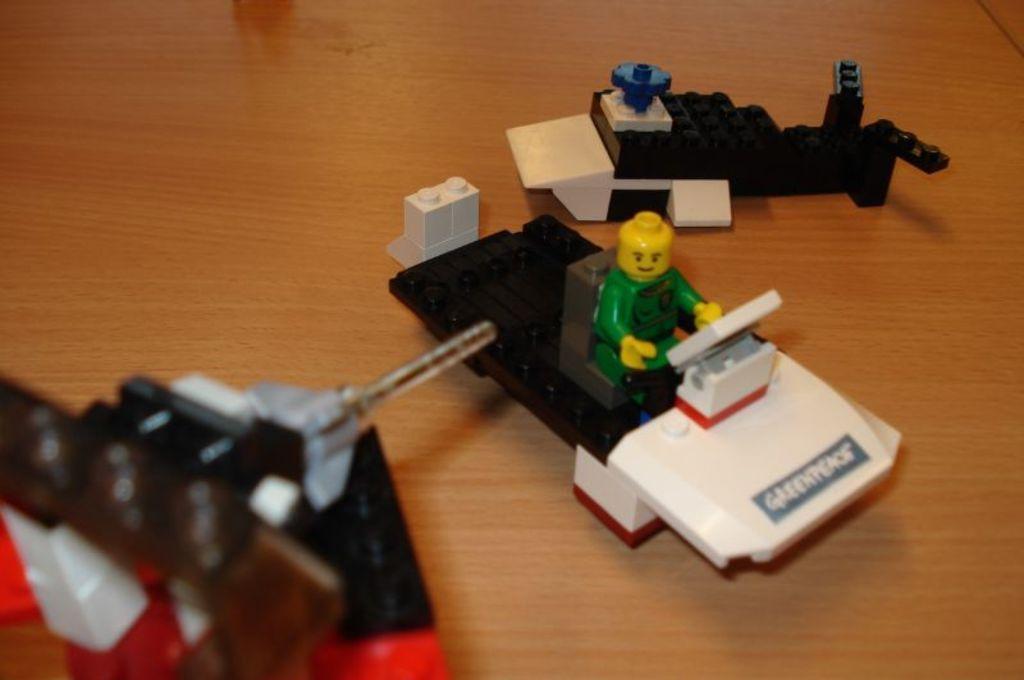Could you give a brief overview of what you see in this image? In image I can see toys and some other objects on a wooden surface. 